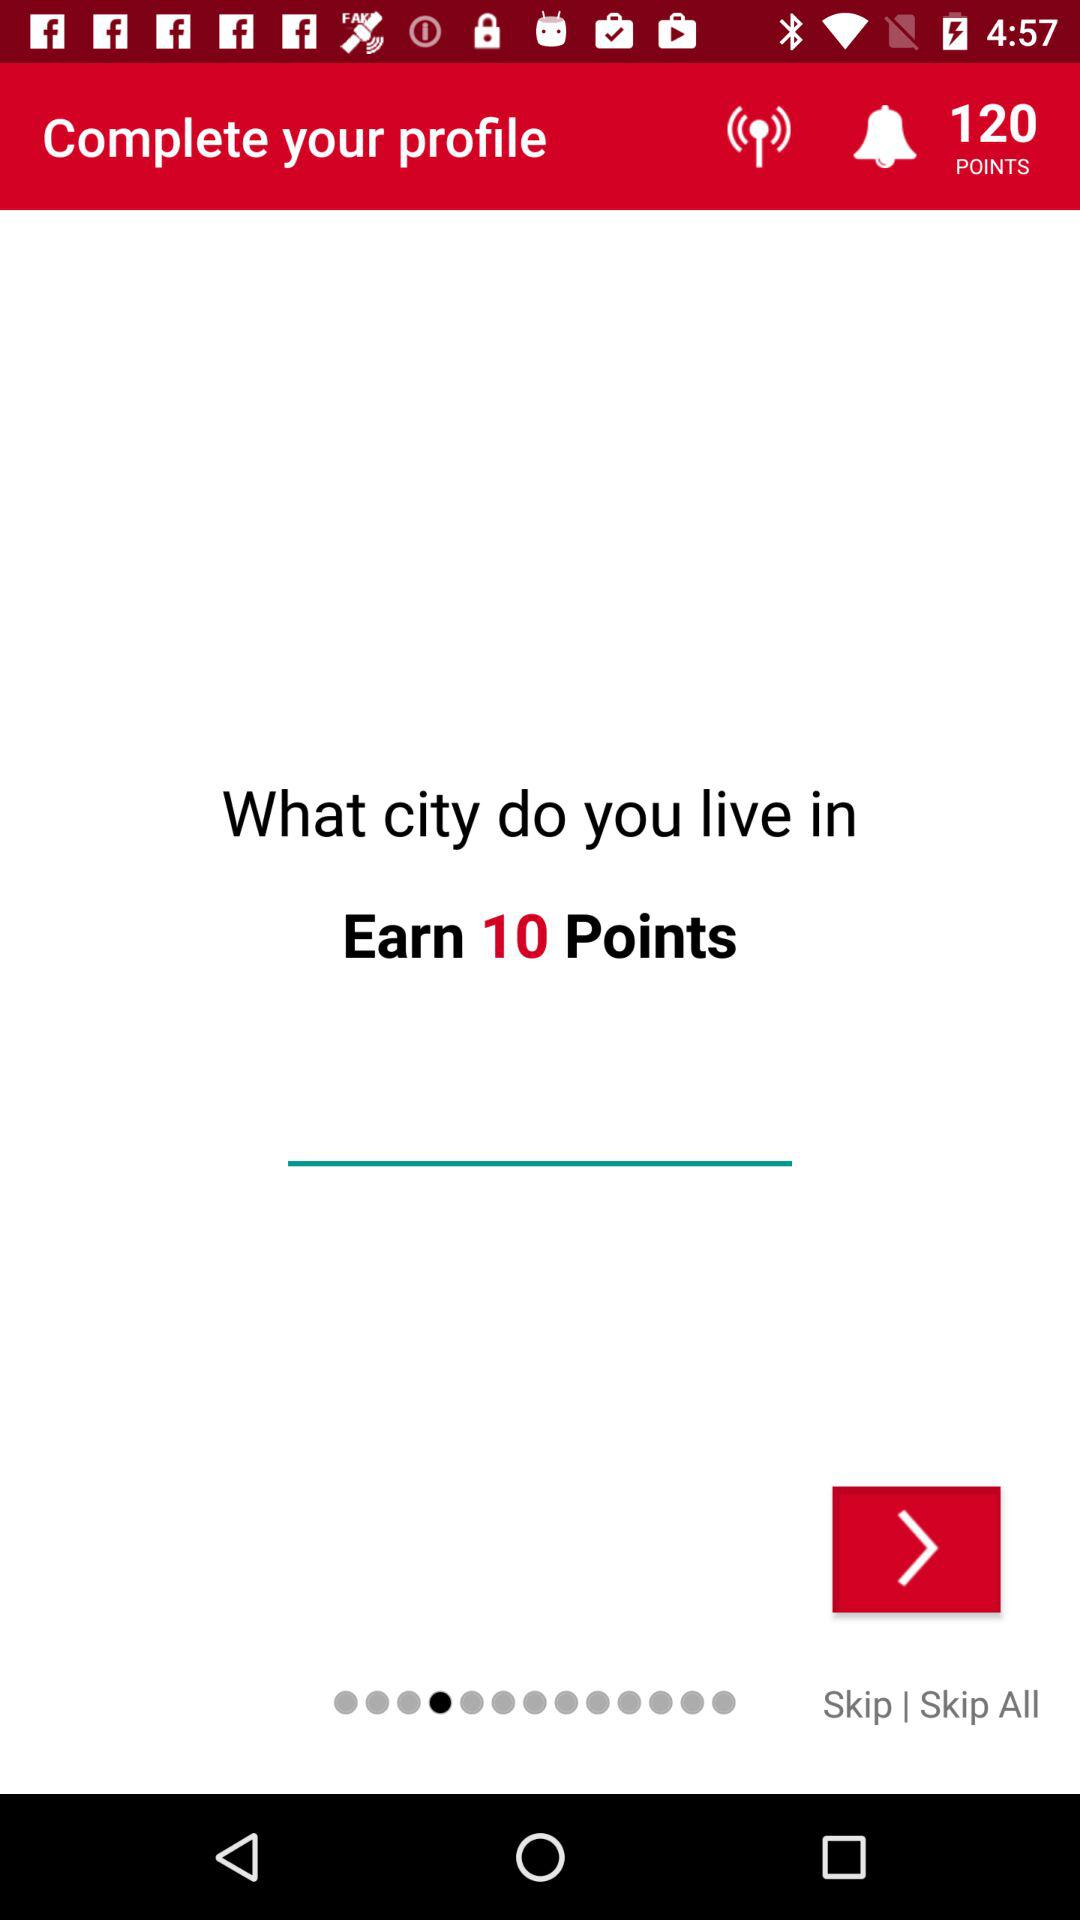How many points are displayed on the screen? There are 120 points displayed on the screen. 